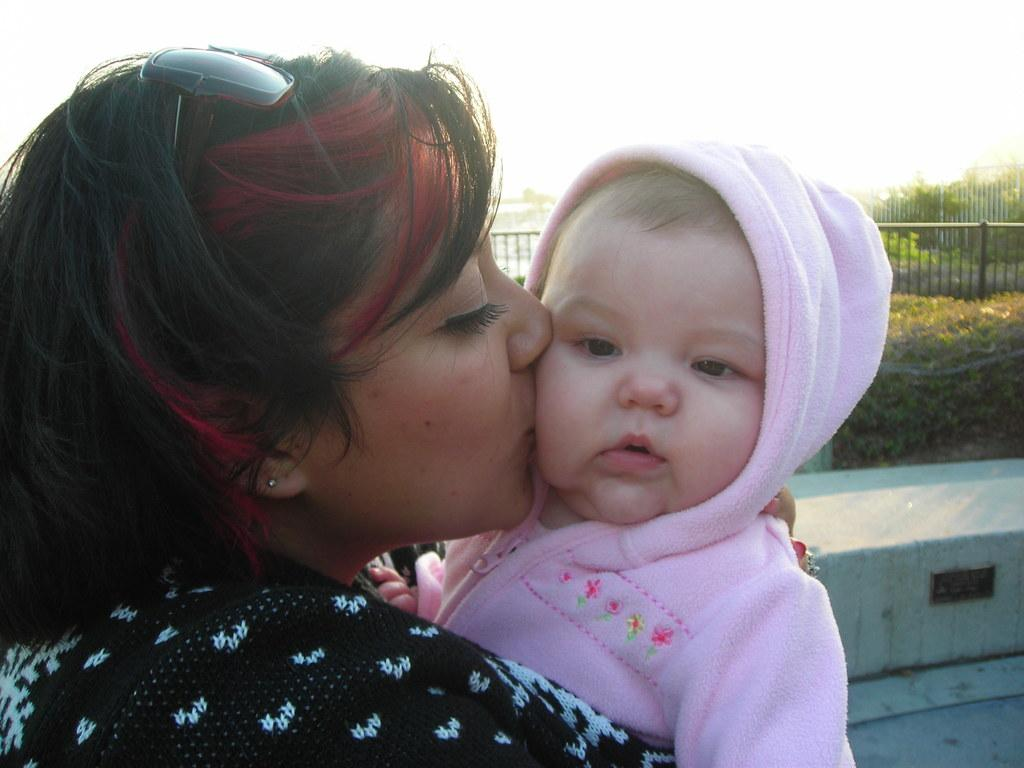Who is the main subject in the center of the image? There is a lady in the center of the image. What is the lady doing in the image? The lady is hugging a baby. What can be seen in the background of the image? There are bushes and fencing in the background of the image. What part of the ground is visible in the image? The ground is visible at the bottom right corner of the image. What type of gold is present in the lady's pocket in the image? There is no mention of gold or pockets in the image, so it cannot be determined if any gold is present. 